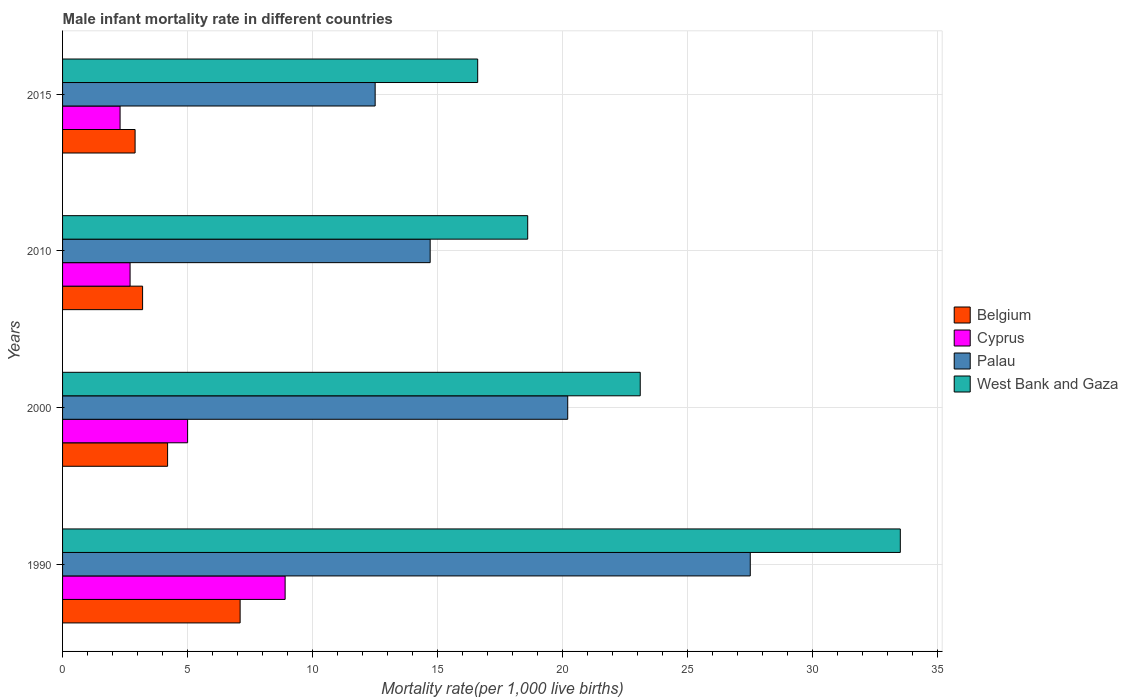How many different coloured bars are there?
Your answer should be compact. 4. How many groups of bars are there?
Make the answer very short. 4. Are the number of bars per tick equal to the number of legend labels?
Offer a very short reply. Yes. Are the number of bars on each tick of the Y-axis equal?
Offer a terse response. Yes. How many bars are there on the 4th tick from the bottom?
Your answer should be very brief. 4. What is the label of the 4th group of bars from the top?
Give a very brief answer. 1990. What is the male infant mortality rate in West Bank and Gaza in 2000?
Provide a short and direct response. 23.1. Across all years, what is the maximum male infant mortality rate in Belgium?
Ensure brevity in your answer.  7.1. In which year was the male infant mortality rate in Palau minimum?
Your response must be concise. 2015. What is the total male infant mortality rate in Belgium in the graph?
Your response must be concise. 17.4. What is the difference between the male infant mortality rate in Cyprus in 1990 and that in 2015?
Ensure brevity in your answer.  6.6. What is the difference between the male infant mortality rate in Palau in 1990 and the male infant mortality rate in Cyprus in 2000?
Give a very brief answer. 22.5. What is the average male infant mortality rate in West Bank and Gaza per year?
Provide a short and direct response. 22.95. In the year 2010, what is the difference between the male infant mortality rate in Palau and male infant mortality rate in Belgium?
Keep it short and to the point. 11.5. In how many years, is the male infant mortality rate in West Bank and Gaza greater than 1 ?
Your answer should be very brief. 4. What is the ratio of the male infant mortality rate in Palau in 2000 to that in 2010?
Make the answer very short. 1.37. What is the difference between the highest and the second highest male infant mortality rate in West Bank and Gaza?
Offer a terse response. 10.4. In how many years, is the male infant mortality rate in Palau greater than the average male infant mortality rate in Palau taken over all years?
Give a very brief answer. 2. What does the 2nd bar from the top in 2000 represents?
Offer a terse response. Palau. What does the 3rd bar from the bottom in 2015 represents?
Keep it short and to the point. Palau. How many bars are there?
Your response must be concise. 16. Are the values on the major ticks of X-axis written in scientific E-notation?
Give a very brief answer. No. Does the graph contain any zero values?
Offer a terse response. No. Does the graph contain grids?
Provide a short and direct response. Yes. Where does the legend appear in the graph?
Make the answer very short. Center right. How many legend labels are there?
Offer a terse response. 4. What is the title of the graph?
Your answer should be compact. Male infant mortality rate in different countries. What is the label or title of the X-axis?
Keep it short and to the point. Mortality rate(per 1,0 live births). What is the Mortality rate(per 1,000 live births) in Belgium in 1990?
Ensure brevity in your answer.  7.1. What is the Mortality rate(per 1,000 live births) in Cyprus in 1990?
Give a very brief answer. 8.9. What is the Mortality rate(per 1,000 live births) of Palau in 1990?
Ensure brevity in your answer.  27.5. What is the Mortality rate(per 1,000 live births) in West Bank and Gaza in 1990?
Give a very brief answer. 33.5. What is the Mortality rate(per 1,000 live births) in Cyprus in 2000?
Your answer should be very brief. 5. What is the Mortality rate(per 1,000 live births) of Palau in 2000?
Provide a succinct answer. 20.2. What is the Mortality rate(per 1,000 live births) in West Bank and Gaza in 2000?
Make the answer very short. 23.1. What is the Mortality rate(per 1,000 live births) in Palau in 2010?
Ensure brevity in your answer.  14.7. What is the Mortality rate(per 1,000 live births) of West Bank and Gaza in 2010?
Your answer should be very brief. 18.6. What is the Mortality rate(per 1,000 live births) in Cyprus in 2015?
Your answer should be compact. 2.3. Across all years, what is the maximum Mortality rate(per 1,000 live births) of Palau?
Your answer should be very brief. 27.5. Across all years, what is the maximum Mortality rate(per 1,000 live births) of West Bank and Gaza?
Make the answer very short. 33.5. Across all years, what is the minimum Mortality rate(per 1,000 live births) of Belgium?
Give a very brief answer. 2.9. Across all years, what is the minimum Mortality rate(per 1,000 live births) in Cyprus?
Keep it short and to the point. 2.3. Across all years, what is the minimum Mortality rate(per 1,000 live births) of Palau?
Your response must be concise. 12.5. What is the total Mortality rate(per 1,000 live births) of Palau in the graph?
Provide a succinct answer. 74.9. What is the total Mortality rate(per 1,000 live births) of West Bank and Gaza in the graph?
Your response must be concise. 91.8. What is the difference between the Mortality rate(per 1,000 live births) in Belgium in 1990 and that in 2000?
Give a very brief answer. 2.9. What is the difference between the Mortality rate(per 1,000 live births) of Belgium in 1990 and that in 2010?
Make the answer very short. 3.9. What is the difference between the Mortality rate(per 1,000 live births) of Cyprus in 1990 and that in 2015?
Provide a succinct answer. 6.6. What is the difference between the Mortality rate(per 1,000 live births) in Palau in 1990 and that in 2015?
Keep it short and to the point. 15. What is the difference between the Mortality rate(per 1,000 live births) of West Bank and Gaza in 1990 and that in 2015?
Offer a terse response. 16.9. What is the difference between the Mortality rate(per 1,000 live births) in West Bank and Gaza in 2000 and that in 2010?
Ensure brevity in your answer.  4.5. What is the difference between the Mortality rate(per 1,000 live births) in Belgium in 2000 and that in 2015?
Your response must be concise. 1.3. What is the difference between the Mortality rate(per 1,000 live births) of Cyprus in 2000 and that in 2015?
Provide a short and direct response. 2.7. What is the difference between the Mortality rate(per 1,000 live births) in West Bank and Gaza in 2000 and that in 2015?
Your answer should be compact. 6.5. What is the difference between the Mortality rate(per 1,000 live births) of West Bank and Gaza in 2010 and that in 2015?
Make the answer very short. 2. What is the difference between the Mortality rate(per 1,000 live births) in Belgium in 1990 and the Mortality rate(per 1,000 live births) in West Bank and Gaza in 2000?
Provide a succinct answer. -16. What is the difference between the Mortality rate(per 1,000 live births) in Cyprus in 1990 and the Mortality rate(per 1,000 live births) in Palau in 2000?
Keep it short and to the point. -11.3. What is the difference between the Mortality rate(per 1,000 live births) in Palau in 1990 and the Mortality rate(per 1,000 live births) in West Bank and Gaza in 2000?
Your answer should be very brief. 4.4. What is the difference between the Mortality rate(per 1,000 live births) in Belgium in 1990 and the Mortality rate(per 1,000 live births) in Cyprus in 2010?
Give a very brief answer. 4.4. What is the difference between the Mortality rate(per 1,000 live births) of Belgium in 1990 and the Mortality rate(per 1,000 live births) of Cyprus in 2015?
Your answer should be very brief. 4.8. What is the difference between the Mortality rate(per 1,000 live births) of Belgium in 1990 and the Mortality rate(per 1,000 live births) of West Bank and Gaza in 2015?
Ensure brevity in your answer.  -9.5. What is the difference between the Mortality rate(per 1,000 live births) of Cyprus in 1990 and the Mortality rate(per 1,000 live births) of Palau in 2015?
Keep it short and to the point. -3.6. What is the difference between the Mortality rate(per 1,000 live births) of Belgium in 2000 and the Mortality rate(per 1,000 live births) of Cyprus in 2010?
Your answer should be very brief. 1.5. What is the difference between the Mortality rate(per 1,000 live births) in Belgium in 2000 and the Mortality rate(per 1,000 live births) in Palau in 2010?
Offer a very short reply. -10.5. What is the difference between the Mortality rate(per 1,000 live births) of Belgium in 2000 and the Mortality rate(per 1,000 live births) of West Bank and Gaza in 2010?
Give a very brief answer. -14.4. What is the difference between the Mortality rate(per 1,000 live births) of Cyprus in 2000 and the Mortality rate(per 1,000 live births) of Palau in 2010?
Keep it short and to the point. -9.7. What is the difference between the Mortality rate(per 1,000 live births) of Belgium in 2000 and the Mortality rate(per 1,000 live births) of West Bank and Gaza in 2015?
Your answer should be very brief. -12.4. What is the difference between the Mortality rate(per 1,000 live births) of Cyprus in 2000 and the Mortality rate(per 1,000 live births) of Palau in 2015?
Keep it short and to the point. -7.5. What is the difference between the Mortality rate(per 1,000 live births) of Belgium in 2010 and the Mortality rate(per 1,000 live births) of Cyprus in 2015?
Provide a succinct answer. 0.9. What is the difference between the Mortality rate(per 1,000 live births) of Belgium in 2010 and the Mortality rate(per 1,000 live births) of Palau in 2015?
Make the answer very short. -9.3. What is the difference between the Mortality rate(per 1,000 live births) of Belgium in 2010 and the Mortality rate(per 1,000 live births) of West Bank and Gaza in 2015?
Make the answer very short. -13.4. What is the average Mortality rate(per 1,000 live births) of Belgium per year?
Provide a short and direct response. 4.35. What is the average Mortality rate(per 1,000 live births) in Cyprus per year?
Your response must be concise. 4.72. What is the average Mortality rate(per 1,000 live births) in Palau per year?
Offer a very short reply. 18.73. What is the average Mortality rate(per 1,000 live births) of West Bank and Gaza per year?
Offer a very short reply. 22.95. In the year 1990, what is the difference between the Mortality rate(per 1,000 live births) in Belgium and Mortality rate(per 1,000 live births) in Cyprus?
Offer a very short reply. -1.8. In the year 1990, what is the difference between the Mortality rate(per 1,000 live births) in Belgium and Mortality rate(per 1,000 live births) in Palau?
Your answer should be very brief. -20.4. In the year 1990, what is the difference between the Mortality rate(per 1,000 live births) of Belgium and Mortality rate(per 1,000 live births) of West Bank and Gaza?
Offer a very short reply. -26.4. In the year 1990, what is the difference between the Mortality rate(per 1,000 live births) in Cyprus and Mortality rate(per 1,000 live births) in Palau?
Ensure brevity in your answer.  -18.6. In the year 1990, what is the difference between the Mortality rate(per 1,000 live births) of Cyprus and Mortality rate(per 1,000 live births) of West Bank and Gaza?
Keep it short and to the point. -24.6. In the year 1990, what is the difference between the Mortality rate(per 1,000 live births) of Palau and Mortality rate(per 1,000 live births) of West Bank and Gaza?
Offer a terse response. -6. In the year 2000, what is the difference between the Mortality rate(per 1,000 live births) in Belgium and Mortality rate(per 1,000 live births) in Cyprus?
Keep it short and to the point. -0.8. In the year 2000, what is the difference between the Mortality rate(per 1,000 live births) of Belgium and Mortality rate(per 1,000 live births) of Palau?
Your answer should be compact. -16. In the year 2000, what is the difference between the Mortality rate(per 1,000 live births) in Belgium and Mortality rate(per 1,000 live births) in West Bank and Gaza?
Keep it short and to the point. -18.9. In the year 2000, what is the difference between the Mortality rate(per 1,000 live births) in Cyprus and Mortality rate(per 1,000 live births) in Palau?
Ensure brevity in your answer.  -15.2. In the year 2000, what is the difference between the Mortality rate(per 1,000 live births) of Cyprus and Mortality rate(per 1,000 live births) of West Bank and Gaza?
Make the answer very short. -18.1. In the year 2000, what is the difference between the Mortality rate(per 1,000 live births) of Palau and Mortality rate(per 1,000 live births) of West Bank and Gaza?
Your response must be concise. -2.9. In the year 2010, what is the difference between the Mortality rate(per 1,000 live births) of Belgium and Mortality rate(per 1,000 live births) of West Bank and Gaza?
Give a very brief answer. -15.4. In the year 2010, what is the difference between the Mortality rate(per 1,000 live births) in Cyprus and Mortality rate(per 1,000 live births) in Palau?
Keep it short and to the point. -12. In the year 2010, what is the difference between the Mortality rate(per 1,000 live births) in Cyprus and Mortality rate(per 1,000 live births) in West Bank and Gaza?
Provide a short and direct response. -15.9. In the year 2010, what is the difference between the Mortality rate(per 1,000 live births) in Palau and Mortality rate(per 1,000 live births) in West Bank and Gaza?
Your answer should be compact. -3.9. In the year 2015, what is the difference between the Mortality rate(per 1,000 live births) in Belgium and Mortality rate(per 1,000 live births) in West Bank and Gaza?
Make the answer very short. -13.7. In the year 2015, what is the difference between the Mortality rate(per 1,000 live births) in Cyprus and Mortality rate(per 1,000 live births) in West Bank and Gaza?
Provide a succinct answer. -14.3. What is the ratio of the Mortality rate(per 1,000 live births) in Belgium in 1990 to that in 2000?
Your answer should be very brief. 1.69. What is the ratio of the Mortality rate(per 1,000 live births) of Cyprus in 1990 to that in 2000?
Make the answer very short. 1.78. What is the ratio of the Mortality rate(per 1,000 live births) of Palau in 1990 to that in 2000?
Give a very brief answer. 1.36. What is the ratio of the Mortality rate(per 1,000 live births) of West Bank and Gaza in 1990 to that in 2000?
Provide a succinct answer. 1.45. What is the ratio of the Mortality rate(per 1,000 live births) of Belgium in 1990 to that in 2010?
Your answer should be compact. 2.22. What is the ratio of the Mortality rate(per 1,000 live births) in Cyprus in 1990 to that in 2010?
Your answer should be compact. 3.3. What is the ratio of the Mortality rate(per 1,000 live births) of Palau in 1990 to that in 2010?
Your answer should be very brief. 1.87. What is the ratio of the Mortality rate(per 1,000 live births) of West Bank and Gaza in 1990 to that in 2010?
Ensure brevity in your answer.  1.8. What is the ratio of the Mortality rate(per 1,000 live births) in Belgium in 1990 to that in 2015?
Offer a terse response. 2.45. What is the ratio of the Mortality rate(per 1,000 live births) of Cyprus in 1990 to that in 2015?
Provide a short and direct response. 3.87. What is the ratio of the Mortality rate(per 1,000 live births) of Palau in 1990 to that in 2015?
Provide a succinct answer. 2.2. What is the ratio of the Mortality rate(per 1,000 live births) of West Bank and Gaza in 1990 to that in 2015?
Keep it short and to the point. 2.02. What is the ratio of the Mortality rate(per 1,000 live births) of Belgium in 2000 to that in 2010?
Your answer should be compact. 1.31. What is the ratio of the Mortality rate(per 1,000 live births) in Cyprus in 2000 to that in 2010?
Offer a very short reply. 1.85. What is the ratio of the Mortality rate(per 1,000 live births) of Palau in 2000 to that in 2010?
Your answer should be very brief. 1.37. What is the ratio of the Mortality rate(per 1,000 live births) in West Bank and Gaza in 2000 to that in 2010?
Offer a terse response. 1.24. What is the ratio of the Mortality rate(per 1,000 live births) in Belgium in 2000 to that in 2015?
Offer a terse response. 1.45. What is the ratio of the Mortality rate(per 1,000 live births) of Cyprus in 2000 to that in 2015?
Provide a succinct answer. 2.17. What is the ratio of the Mortality rate(per 1,000 live births) of Palau in 2000 to that in 2015?
Offer a terse response. 1.62. What is the ratio of the Mortality rate(per 1,000 live births) of West Bank and Gaza in 2000 to that in 2015?
Ensure brevity in your answer.  1.39. What is the ratio of the Mortality rate(per 1,000 live births) of Belgium in 2010 to that in 2015?
Provide a succinct answer. 1.1. What is the ratio of the Mortality rate(per 1,000 live births) in Cyprus in 2010 to that in 2015?
Keep it short and to the point. 1.17. What is the ratio of the Mortality rate(per 1,000 live births) in Palau in 2010 to that in 2015?
Give a very brief answer. 1.18. What is the ratio of the Mortality rate(per 1,000 live births) in West Bank and Gaza in 2010 to that in 2015?
Offer a very short reply. 1.12. What is the difference between the highest and the second highest Mortality rate(per 1,000 live births) in Belgium?
Ensure brevity in your answer.  2.9. What is the difference between the highest and the lowest Mortality rate(per 1,000 live births) in Belgium?
Ensure brevity in your answer.  4.2. What is the difference between the highest and the lowest Mortality rate(per 1,000 live births) of Cyprus?
Your response must be concise. 6.6. What is the difference between the highest and the lowest Mortality rate(per 1,000 live births) of West Bank and Gaza?
Ensure brevity in your answer.  16.9. 